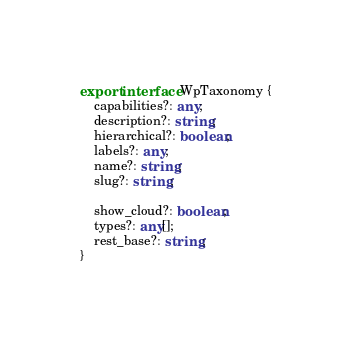<code> <loc_0><loc_0><loc_500><loc_500><_TypeScript_>export interface WpTaxonomy {
    capabilities?: any;
    description?: string;
    hierarchical?: boolean;
    labels?: any;
    name?: string;
    slug?: string;

    show_cloud?: boolean;
    types?: any[];
    rest_base?: string;
}
</code> 